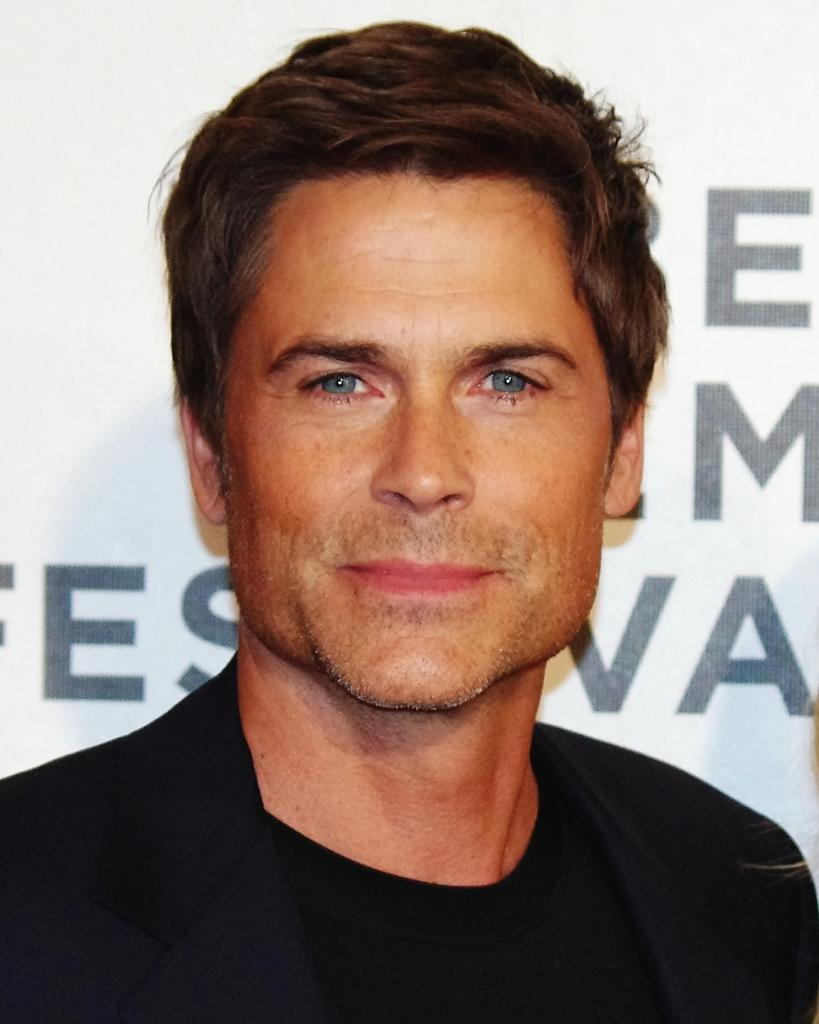Who is present in the image? There is a man in the image. What is the man wearing? The man is wearing a black suit. What can be seen in the background of the image? There is a board in the background of the image. What is written or displayed on the board? There is text on the board. How many goldfish are swimming in the background of the image? There are no goldfish present in the image. What emotion does the man express towards the text on the board? The image does not convey any emotions or expressions from the man, so it cannot be determined how he feels about the text on the board. 